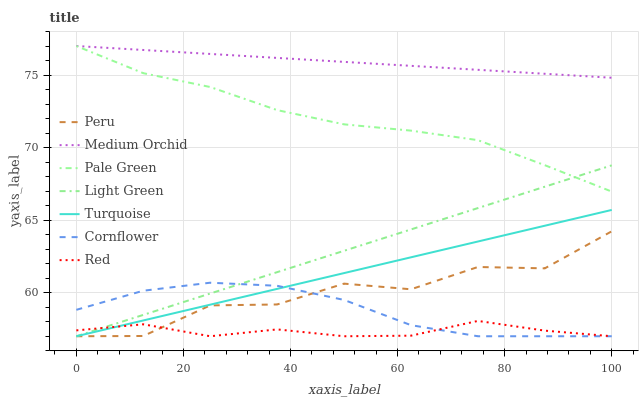Does Red have the minimum area under the curve?
Answer yes or no. Yes. Does Medium Orchid have the maximum area under the curve?
Answer yes or no. Yes. Does Turquoise have the minimum area under the curve?
Answer yes or no. No. Does Turquoise have the maximum area under the curve?
Answer yes or no. No. Is Light Green the smoothest?
Answer yes or no. Yes. Is Peru the roughest?
Answer yes or no. Yes. Is Turquoise the smoothest?
Answer yes or no. No. Is Turquoise the roughest?
Answer yes or no. No. Does Medium Orchid have the lowest value?
Answer yes or no. No. Does Pale Green have the highest value?
Answer yes or no. Yes. Does Turquoise have the highest value?
Answer yes or no. No. Is Cornflower less than Medium Orchid?
Answer yes or no. Yes. Is Medium Orchid greater than Red?
Answer yes or no. Yes. Does Cornflower intersect Peru?
Answer yes or no. Yes. Is Cornflower less than Peru?
Answer yes or no. No. Is Cornflower greater than Peru?
Answer yes or no. No. Does Cornflower intersect Medium Orchid?
Answer yes or no. No. 